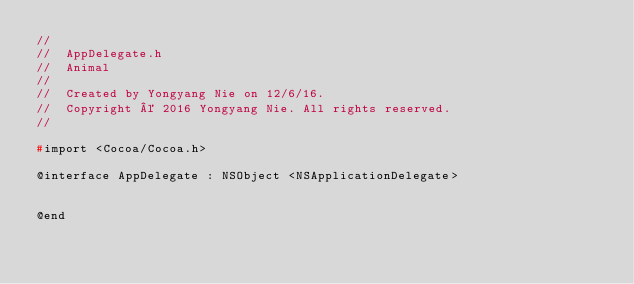Convert code to text. <code><loc_0><loc_0><loc_500><loc_500><_C_>//
//  AppDelegate.h
//  Animal
//
//  Created by Yongyang Nie on 12/6/16.
//  Copyright © 2016 Yongyang Nie. All rights reserved.
//

#import <Cocoa/Cocoa.h>

@interface AppDelegate : NSObject <NSApplicationDelegate>


@end

</code> 